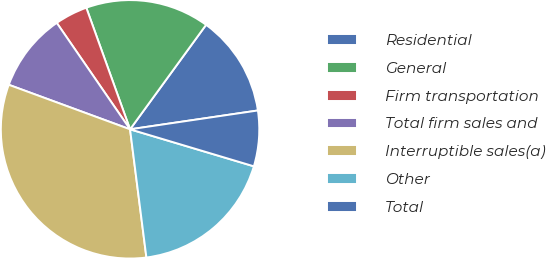Convert chart. <chart><loc_0><loc_0><loc_500><loc_500><pie_chart><fcel>Residential<fcel>General<fcel>Firm transportation<fcel>Total firm sales and<fcel>Interruptible sales(a)<fcel>Other<fcel>Total<nl><fcel>12.66%<fcel>15.51%<fcel>4.1%<fcel>9.8%<fcel>32.62%<fcel>18.36%<fcel>6.95%<nl></chart> 